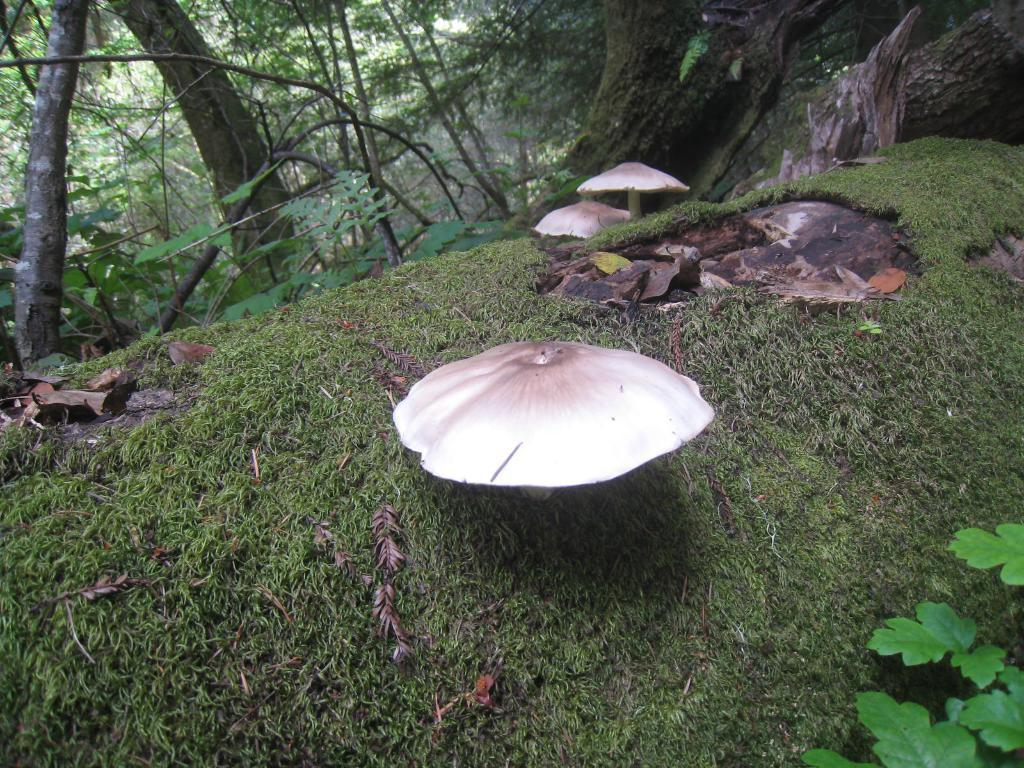What is growing on the tree trunk in the image? There are mushrooms on a tree trunk in the image. What can be seen in the background of the image? There are trees visible in the background of the image. What type of toothbrush is hanging from the tree in the image? There is no toothbrush present in the image. 